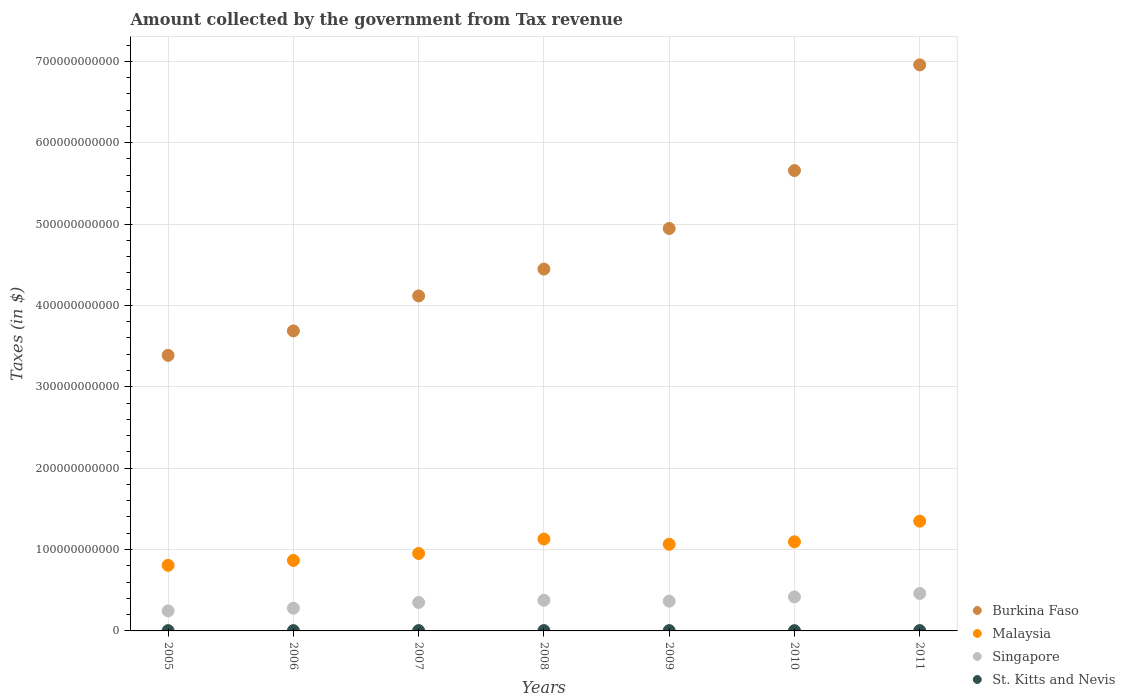Is the number of dotlines equal to the number of legend labels?
Offer a terse response. Yes. What is the amount collected by the government from tax revenue in Malaysia in 2006?
Give a very brief answer. 8.66e+1. Across all years, what is the maximum amount collected by the government from tax revenue in Burkina Faso?
Offer a very short reply. 6.96e+11. Across all years, what is the minimum amount collected by the government from tax revenue in Burkina Faso?
Provide a short and direct response. 3.39e+11. What is the total amount collected by the government from tax revenue in St. Kitts and Nevis in the graph?
Make the answer very short. 2.68e+09. What is the difference between the amount collected by the government from tax revenue in Singapore in 2005 and that in 2006?
Offer a very short reply. -3.31e+09. What is the difference between the amount collected by the government from tax revenue in Burkina Faso in 2010 and the amount collected by the government from tax revenue in Malaysia in 2007?
Give a very brief answer. 4.71e+11. What is the average amount collected by the government from tax revenue in Singapore per year?
Your answer should be very brief. 3.57e+1. In the year 2007, what is the difference between the amount collected by the government from tax revenue in Burkina Faso and amount collected by the government from tax revenue in Malaysia?
Keep it short and to the point. 3.17e+11. In how many years, is the amount collected by the government from tax revenue in Burkina Faso greater than 700000000000 $?
Your answer should be very brief. 0. What is the ratio of the amount collected by the government from tax revenue in Malaysia in 2006 to that in 2010?
Your answer should be very brief. 0.79. Is the amount collected by the government from tax revenue in Malaysia in 2006 less than that in 2010?
Give a very brief answer. Yes. What is the difference between the highest and the second highest amount collected by the government from tax revenue in Singapore?
Your response must be concise. 4.24e+09. What is the difference between the highest and the lowest amount collected by the government from tax revenue in Malaysia?
Offer a very short reply. 5.43e+1. Is the sum of the amount collected by the government from tax revenue in Burkina Faso in 2006 and 2008 greater than the maximum amount collected by the government from tax revenue in Singapore across all years?
Give a very brief answer. Yes. How many years are there in the graph?
Offer a terse response. 7. What is the difference between two consecutive major ticks on the Y-axis?
Keep it short and to the point. 1.00e+11. Does the graph contain any zero values?
Provide a succinct answer. No. Does the graph contain grids?
Ensure brevity in your answer.  Yes. What is the title of the graph?
Offer a very short reply. Amount collected by the government from Tax revenue. Does "Nicaragua" appear as one of the legend labels in the graph?
Your answer should be compact. No. What is the label or title of the Y-axis?
Ensure brevity in your answer.  Taxes (in $). What is the Taxes (in $) in Burkina Faso in 2005?
Your answer should be very brief. 3.39e+11. What is the Taxes (in $) in Malaysia in 2005?
Keep it short and to the point. 8.06e+1. What is the Taxes (in $) of Singapore in 2005?
Offer a very short reply. 2.46e+1. What is the Taxes (in $) in St. Kitts and Nevis in 2005?
Your answer should be compact. 3.44e+08. What is the Taxes (in $) of Burkina Faso in 2006?
Your answer should be compact. 3.69e+11. What is the Taxes (in $) of Malaysia in 2006?
Keep it short and to the point. 8.66e+1. What is the Taxes (in $) in Singapore in 2006?
Provide a succinct answer. 2.79e+1. What is the Taxes (in $) in St. Kitts and Nevis in 2006?
Offer a terse response. 3.74e+08. What is the Taxes (in $) in Burkina Faso in 2007?
Offer a terse response. 4.12e+11. What is the Taxes (in $) in Malaysia in 2007?
Provide a short and direct response. 9.52e+1. What is the Taxes (in $) in Singapore in 2007?
Your answer should be very brief. 3.50e+1. What is the Taxes (in $) in St. Kitts and Nevis in 2007?
Provide a succinct answer. 4.00e+08. What is the Taxes (in $) of Burkina Faso in 2008?
Your answer should be compact. 4.45e+11. What is the Taxes (in $) of Malaysia in 2008?
Ensure brevity in your answer.  1.13e+11. What is the Taxes (in $) in Singapore in 2008?
Keep it short and to the point. 3.77e+1. What is the Taxes (in $) of St. Kitts and Nevis in 2008?
Your response must be concise. 4.21e+08. What is the Taxes (in $) of Burkina Faso in 2009?
Make the answer very short. 4.95e+11. What is the Taxes (in $) of Malaysia in 2009?
Provide a short and direct response. 1.07e+11. What is the Taxes (in $) in Singapore in 2009?
Your response must be concise. 3.66e+1. What is the Taxes (in $) of St. Kitts and Nevis in 2009?
Provide a short and direct response. 3.94e+08. What is the Taxes (in $) of Burkina Faso in 2010?
Keep it short and to the point. 5.66e+11. What is the Taxes (in $) in Malaysia in 2010?
Keep it short and to the point. 1.10e+11. What is the Taxes (in $) in Singapore in 2010?
Provide a succinct answer. 4.18e+1. What is the Taxes (in $) in St. Kitts and Nevis in 2010?
Provide a succinct answer. 3.43e+08. What is the Taxes (in $) in Burkina Faso in 2011?
Make the answer very short. 6.96e+11. What is the Taxes (in $) of Malaysia in 2011?
Give a very brief answer. 1.35e+11. What is the Taxes (in $) of Singapore in 2011?
Your answer should be very brief. 4.60e+1. What is the Taxes (in $) of St. Kitts and Nevis in 2011?
Your answer should be very brief. 4.08e+08. Across all years, what is the maximum Taxes (in $) of Burkina Faso?
Keep it short and to the point. 6.96e+11. Across all years, what is the maximum Taxes (in $) of Malaysia?
Keep it short and to the point. 1.35e+11. Across all years, what is the maximum Taxes (in $) of Singapore?
Give a very brief answer. 4.60e+1. Across all years, what is the maximum Taxes (in $) in St. Kitts and Nevis?
Your answer should be very brief. 4.21e+08. Across all years, what is the minimum Taxes (in $) in Burkina Faso?
Offer a terse response. 3.39e+11. Across all years, what is the minimum Taxes (in $) in Malaysia?
Ensure brevity in your answer.  8.06e+1. Across all years, what is the minimum Taxes (in $) of Singapore?
Your response must be concise. 2.46e+1. Across all years, what is the minimum Taxes (in $) of St. Kitts and Nevis?
Your answer should be compact. 3.43e+08. What is the total Taxes (in $) of Burkina Faso in the graph?
Keep it short and to the point. 3.32e+12. What is the total Taxes (in $) of Malaysia in the graph?
Your answer should be compact. 7.26e+11. What is the total Taxes (in $) of Singapore in the graph?
Give a very brief answer. 2.50e+11. What is the total Taxes (in $) of St. Kitts and Nevis in the graph?
Provide a short and direct response. 2.68e+09. What is the difference between the Taxes (in $) in Burkina Faso in 2005 and that in 2006?
Offer a terse response. -3.00e+1. What is the difference between the Taxes (in $) of Malaysia in 2005 and that in 2006?
Your answer should be compact. -6.04e+09. What is the difference between the Taxes (in $) of Singapore in 2005 and that in 2006?
Give a very brief answer. -3.31e+09. What is the difference between the Taxes (in $) in St. Kitts and Nevis in 2005 and that in 2006?
Keep it short and to the point. -3.00e+07. What is the difference between the Taxes (in $) in Burkina Faso in 2005 and that in 2007?
Provide a short and direct response. -7.30e+1. What is the difference between the Taxes (in $) in Malaysia in 2005 and that in 2007?
Offer a terse response. -1.46e+1. What is the difference between the Taxes (in $) in Singapore in 2005 and that in 2007?
Give a very brief answer. -1.03e+1. What is the difference between the Taxes (in $) in St. Kitts and Nevis in 2005 and that in 2007?
Ensure brevity in your answer.  -5.55e+07. What is the difference between the Taxes (in $) in Burkina Faso in 2005 and that in 2008?
Make the answer very short. -1.06e+11. What is the difference between the Taxes (in $) in Malaysia in 2005 and that in 2008?
Offer a terse response. -3.23e+1. What is the difference between the Taxes (in $) in Singapore in 2005 and that in 2008?
Make the answer very short. -1.31e+1. What is the difference between the Taxes (in $) in St. Kitts and Nevis in 2005 and that in 2008?
Your answer should be compact. -7.66e+07. What is the difference between the Taxes (in $) of Burkina Faso in 2005 and that in 2009?
Ensure brevity in your answer.  -1.56e+11. What is the difference between the Taxes (in $) of Malaysia in 2005 and that in 2009?
Provide a short and direct response. -2.59e+1. What is the difference between the Taxes (in $) of Singapore in 2005 and that in 2009?
Your answer should be compact. -1.20e+1. What is the difference between the Taxes (in $) in St. Kitts and Nevis in 2005 and that in 2009?
Offer a very short reply. -5.04e+07. What is the difference between the Taxes (in $) in Burkina Faso in 2005 and that in 2010?
Provide a succinct answer. -2.27e+11. What is the difference between the Taxes (in $) of Malaysia in 2005 and that in 2010?
Ensure brevity in your answer.  -2.89e+1. What is the difference between the Taxes (in $) in Singapore in 2005 and that in 2010?
Provide a succinct answer. -1.72e+1. What is the difference between the Taxes (in $) of St. Kitts and Nevis in 2005 and that in 2010?
Offer a terse response. 1.10e+06. What is the difference between the Taxes (in $) in Burkina Faso in 2005 and that in 2011?
Your answer should be compact. -3.57e+11. What is the difference between the Taxes (in $) of Malaysia in 2005 and that in 2011?
Provide a succinct answer. -5.43e+1. What is the difference between the Taxes (in $) in Singapore in 2005 and that in 2011?
Make the answer very short. -2.14e+1. What is the difference between the Taxes (in $) of St. Kitts and Nevis in 2005 and that in 2011?
Your answer should be very brief. -6.39e+07. What is the difference between the Taxes (in $) in Burkina Faso in 2006 and that in 2007?
Your answer should be compact. -4.30e+1. What is the difference between the Taxes (in $) in Malaysia in 2006 and that in 2007?
Your answer should be compact. -8.54e+09. What is the difference between the Taxes (in $) of Singapore in 2006 and that in 2007?
Give a very brief answer. -7.02e+09. What is the difference between the Taxes (in $) in St. Kitts and Nevis in 2006 and that in 2007?
Your response must be concise. -2.55e+07. What is the difference between the Taxes (in $) of Burkina Faso in 2006 and that in 2008?
Your answer should be very brief. -7.60e+1. What is the difference between the Taxes (in $) in Malaysia in 2006 and that in 2008?
Provide a succinct answer. -2.63e+1. What is the difference between the Taxes (in $) in Singapore in 2006 and that in 2008?
Your answer should be very brief. -9.74e+09. What is the difference between the Taxes (in $) of St. Kitts and Nevis in 2006 and that in 2008?
Provide a succinct answer. -4.66e+07. What is the difference between the Taxes (in $) of Burkina Faso in 2006 and that in 2009?
Provide a succinct answer. -1.26e+11. What is the difference between the Taxes (in $) in Malaysia in 2006 and that in 2009?
Offer a very short reply. -1.99e+1. What is the difference between the Taxes (in $) of Singapore in 2006 and that in 2009?
Provide a succinct answer. -8.64e+09. What is the difference between the Taxes (in $) of St. Kitts and Nevis in 2006 and that in 2009?
Give a very brief answer. -2.04e+07. What is the difference between the Taxes (in $) of Burkina Faso in 2006 and that in 2010?
Provide a succinct answer. -1.97e+11. What is the difference between the Taxes (in $) of Malaysia in 2006 and that in 2010?
Your response must be concise. -2.29e+1. What is the difference between the Taxes (in $) of Singapore in 2006 and that in 2010?
Your response must be concise. -1.39e+1. What is the difference between the Taxes (in $) in St. Kitts and Nevis in 2006 and that in 2010?
Ensure brevity in your answer.  3.11e+07. What is the difference between the Taxes (in $) of Burkina Faso in 2006 and that in 2011?
Provide a short and direct response. -3.27e+11. What is the difference between the Taxes (in $) in Malaysia in 2006 and that in 2011?
Your response must be concise. -4.83e+1. What is the difference between the Taxes (in $) of Singapore in 2006 and that in 2011?
Give a very brief answer. -1.81e+1. What is the difference between the Taxes (in $) of St. Kitts and Nevis in 2006 and that in 2011?
Ensure brevity in your answer.  -3.39e+07. What is the difference between the Taxes (in $) of Burkina Faso in 2007 and that in 2008?
Your response must be concise. -3.30e+1. What is the difference between the Taxes (in $) of Malaysia in 2007 and that in 2008?
Offer a very short reply. -1.77e+1. What is the difference between the Taxes (in $) in Singapore in 2007 and that in 2008?
Keep it short and to the point. -2.72e+09. What is the difference between the Taxes (in $) of St. Kitts and Nevis in 2007 and that in 2008?
Offer a terse response. -2.11e+07. What is the difference between the Taxes (in $) of Burkina Faso in 2007 and that in 2009?
Offer a terse response. -8.29e+1. What is the difference between the Taxes (in $) of Malaysia in 2007 and that in 2009?
Provide a short and direct response. -1.13e+1. What is the difference between the Taxes (in $) of Singapore in 2007 and that in 2009?
Your answer should be very brief. -1.62e+09. What is the difference between the Taxes (in $) of St. Kitts and Nevis in 2007 and that in 2009?
Your response must be concise. 5.10e+06. What is the difference between the Taxes (in $) of Burkina Faso in 2007 and that in 2010?
Offer a very short reply. -1.54e+11. What is the difference between the Taxes (in $) of Malaysia in 2007 and that in 2010?
Keep it short and to the point. -1.43e+1. What is the difference between the Taxes (in $) in Singapore in 2007 and that in 2010?
Your answer should be compact. -6.85e+09. What is the difference between the Taxes (in $) in St. Kitts and Nevis in 2007 and that in 2010?
Your answer should be compact. 5.66e+07. What is the difference between the Taxes (in $) of Burkina Faso in 2007 and that in 2011?
Your answer should be compact. -2.84e+11. What is the difference between the Taxes (in $) of Malaysia in 2007 and that in 2011?
Provide a short and direct response. -3.97e+1. What is the difference between the Taxes (in $) in Singapore in 2007 and that in 2011?
Ensure brevity in your answer.  -1.11e+1. What is the difference between the Taxes (in $) of St. Kitts and Nevis in 2007 and that in 2011?
Provide a succinct answer. -8.40e+06. What is the difference between the Taxes (in $) of Burkina Faso in 2008 and that in 2009?
Your answer should be very brief. -4.99e+1. What is the difference between the Taxes (in $) in Malaysia in 2008 and that in 2009?
Make the answer very short. 6.39e+09. What is the difference between the Taxes (in $) in Singapore in 2008 and that in 2009?
Keep it short and to the point. 1.10e+09. What is the difference between the Taxes (in $) of St. Kitts and Nevis in 2008 and that in 2009?
Provide a short and direct response. 2.62e+07. What is the difference between the Taxes (in $) of Burkina Faso in 2008 and that in 2010?
Your response must be concise. -1.21e+11. What is the difference between the Taxes (in $) in Malaysia in 2008 and that in 2010?
Ensure brevity in your answer.  3.38e+09. What is the difference between the Taxes (in $) of Singapore in 2008 and that in 2010?
Give a very brief answer. -4.13e+09. What is the difference between the Taxes (in $) of St. Kitts and Nevis in 2008 and that in 2010?
Make the answer very short. 7.77e+07. What is the difference between the Taxes (in $) of Burkina Faso in 2008 and that in 2011?
Give a very brief answer. -2.51e+11. What is the difference between the Taxes (in $) in Malaysia in 2008 and that in 2011?
Make the answer very short. -2.20e+1. What is the difference between the Taxes (in $) of Singapore in 2008 and that in 2011?
Offer a terse response. -8.37e+09. What is the difference between the Taxes (in $) of St. Kitts and Nevis in 2008 and that in 2011?
Make the answer very short. 1.27e+07. What is the difference between the Taxes (in $) of Burkina Faso in 2009 and that in 2010?
Keep it short and to the point. -7.12e+1. What is the difference between the Taxes (in $) in Malaysia in 2009 and that in 2010?
Make the answer very short. -3.01e+09. What is the difference between the Taxes (in $) of Singapore in 2009 and that in 2010?
Your response must be concise. -5.22e+09. What is the difference between the Taxes (in $) in St. Kitts and Nevis in 2009 and that in 2010?
Your answer should be compact. 5.15e+07. What is the difference between the Taxes (in $) in Burkina Faso in 2009 and that in 2011?
Offer a terse response. -2.01e+11. What is the difference between the Taxes (in $) of Malaysia in 2009 and that in 2011?
Offer a terse response. -2.84e+1. What is the difference between the Taxes (in $) in Singapore in 2009 and that in 2011?
Provide a short and direct response. -9.47e+09. What is the difference between the Taxes (in $) in St. Kitts and Nevis in 2009 and that in 2011?
Your response must be concise. -1.35e+07. What is the difference between the Taxes (in $) of Burkina Faso in 2010 and that in 2011?
Your answer should be very brief. -1.30e+11. What is the difference between the Taxes (in $) in Malaysia in 2010 and that in 2011?
Keep it short and to the point. -2.54e+1. What is the difference between the Taxes (in $) in Singapore in 2010 and that in 2011?
Offer a very short reply. -4.24e+09. What is the difference between the Taxes (in $) in St. Kitts and Nevis in 2010 and that in 2011?
Your answer should be compact. -6.50e+07. What is the difference between the Taxes (in $) in Burkina Faso in 2005 and the Taxes (in $) in Malaysia in 2006?
Give a very brief answer. 2.52e+11. What is the difference between the Taxes (in $) of Burkina Faso in 2005 and the Taxes (in $) of Singapore in 2006?
Offer a terse response. 3.11e+11. What is the difference between the Taxes (in $) in Burkina Faso in 2005 and the Taxes (in $) in St. Kitts and Nevis in 2006?
Offer a very short reply. 3.38e+11. What is the difference between the Taxes (in $) in Malaysia in 2005 and the Taxes (in $) in Singapore in 2006?
Provide a succinct answer. 5.27e+1. What is the difference between the Taxes (in $) in Malaysia in 2005 and the Taxes (in $) in St. Kitts and Nevis in 2006?
Your answer should be very brief. 8.02e+1. What is the difference between the Taxes (in $) of Singapore in 2005 and the Taxes (in $) of St. Kitts and Nevis in 2006?
Ensure brevity in your answer.  2.43e+1. What is the difference between the Taxes (in $) of Burkina Faso in 2005 and the Taxes (in $) of Malaysia in 2007?
Make the answer very short. 2.43e+11. What is the difference between the Taxes (in $) in Burkina Faso in 2005 and the Taxes (in $) in Singapore in 2007?
Give a very brief answer. 3.04e+11. What is the difference between the Taxes (in $) of Burkina Faso in 2005 and the Taxes (in $) of St. Kitts and Nevis in 2007?
Provide a succinct answer. 3.38e+11. What is the difference between the Taxes (in $) in Malaysia in 2005 and the Taxes (in $) in Singapore in 2007?
Provide a succinct answer. 4.56e+1. What is the difference between the Taxes (in $) in Malaysia in 2005 and the Taxes (in $) in St. Kitts and Nevis in 2007?
Offer a very short reply. 8.02e+1. What is the difference between the Taxes (in $) of Singapore in 2005 and the Taxes (in $) of St. Kitts and Nevis in 2007?
Your answer should be compact. 2.42e+1. What is the difference between the Taxes (in $) of Burkina Faso in 2005 and the Taxes (in $) of Malaysia in 2008?
Your answer should be compact. 2.26e+11. What is the difference between the Taxes (in $) of Burkina Faso in 2005 and the Taxes (in $) of Singapore in 2008?
Your answer should be very brief. 3.01e+11. What is the difference between the Taxes (in $) of Burkina Faso in 2005 and the Taxes (in $) of St. Kitts and Nevis in 2008?
Ensure brevity in your answer.  3.38e+11. What is the difference between the Taxes (in $) in Malaysia in 2005 and the Taxes (in $) in Singapore in 2008?
Your response must be concise. 4.29e+1. What is the difference between the Taxes (in $) of Malaysia in 2005 and the Taxes (in $) of St. Kitts and Nevis in 2008?
Give a very brief answer. 8.02e+1. What is the difference between the Taxes (in $) of Singapore in 2005 and the Taxes (in $) of St. Kitts and Nevis in 2008?
Your response must be concise. 2.42e+1. What is the difference between the Taxes (in $) of Burkina Faso in 2005 and the Taxes (in $) of Malaysia in 2009?
Your answer should be compact. 2.32e+11. What is the difference between the Taxes (in $) of Burkina Faso in 2005 and the Taxes (in $) of Singapore in 2009?
Your response must be concise. 3.02e+11. What is the difference between the Taxes (in $) in Burkina Faso in 2005 and the Taxes (in $) in St. Kitts and Nevis in 2009?
Provide a succinct answer. 3.38e+11. What is the difference between the Taxes (in $) in Malaysia in 2005 and the Taxes (in $) in Singapore in 2009?
Your answer should be very brief. 4.40e+1. What is the difference between the Taxes (in $) of Malaysia in 2005 and the Taxes (in $) of St. Kitts and Nevis in 2009?
Provide a short and direct response. 8.02e+1. What is the difference between the Taxes (in $) of Singapore in 2005 and the Taxes (in $) of St. Kitts and Nevis in 2009?
Ensure brevity in your answer.  2.42e+1. What is the difference between the Taxes (in $) in Burkina Faso in 2005 and the Taxes (in $) in Malaysia in 2010?
Your response must be concise. 2.29e+11. What is the difference between the Taxes (in $) of Burkina Faso in 2005 and the Taxes (in $) of Singapore in 2010?
Give a very brief answer. 2.97e+11. What is the difference between the Taxes (in $) of Burkina Faso in 2005 and the Taxes (in $) of St. Kitts and Nevis in 2010?
Keep it short and to the point. 3.38e+11. What is the difference between the Taxes (in $) of Malaysia in 2005 and the Taxes (in $) of Singapore in 2010?
Provide a short and direct response. 3.88e+1. What is the difference between the Taxes (in $) of Malaysia in 2005 and the Taxes (in $) of St. Kitts and Nevis in 2010?
Provide a short and direct response. 8.02e+1. What is the difference between the Taxes (in $) of Singapore in 2005 and the Taxes (in $) of St. Kitts and Nevis in 2010?
Ensure brevity in your answer.  2.43e+1. What is the difference between the Taxes (in $) of Burkina Faso in 2005 and the Taxes (in $) of Malaysia in 2011?
Give a very brief answer. 2.04e+11. What is the difference between the Taxes (in $) in Burkina Faso in 2005 and the Taxes (in $) in Singapore in 2011?
Your answer should be compact. 2.93e+11. What is the difference between the Taxes (in $) of Burkina Faso in 2005 and the Taxes (in $) of St. Kitts and Nevis in 2011?
Provide a short and direct response. 3.38e+11. What is the difference between the Taxes (in $) in Malaysia in 2005 and the Taxes (in $) in Singapore in 2011?
Your answer should be compact. 3.45e+1. What is the difference between the Taxes (in $) in Malaysia in 2005 and the Taxes (in $) in St. Kitts and Nevis in 2011?
Offer a very short reply. 8.02e+1. What is the difference between the Taxes (in $) of Singapore in 2005 and the Taxes (in $) of St. Kitts and Nevis in 2011?
Make the answer very short. 2.42e+1. What is the difference between the Taxes (in $) of Burkina Faso in 2006 and the Taxes (in $) of Malaysia in 2007?
Provide a short and direct response. 2.74e+11. What is the difference between the Taxes (in $) in Burkina Faso in 2006 and the Taxes (in $) in Singapore in 2007?
Keep it short and to the point. 3.34e+11. What is the difference between the Taxes (in $) in Burkina Faso in 2006 and the Taxes (in $) in St. Kitts and Nevis in 2007?
Your answer should be very brief. 3.68e+11. What is the difference between the Taxes (in $) in Malaysia in 2006 and the Taxes (in $) in Singapore in 2007?
Make the answer very short. 5.17e+1. What is the difference between the Taxes (in $) of Malaysia in 2006 and the Taxes (in $) of St. Kitts and Nevis in 2007?
Give a very brief answer. 8.62e+1. What is the difference between the Taxes (in $) of Singapore in 2006 and the Taxes (in $) of St. Kitts and Nevis in 2007?
Give a very brief answer. 2.75e+1. What is the difference between the Taxes (in $) of Burkina Faso in 2006 and the Taxes (in $) of Malaysia in 2008?
Offer a terse response. 2.56e+11. What is the difference between the Taxes (in $) of Burkina Faso in 2006 and the Taxes (in $) of Singapore in 2008?
Your answer should be compact. 3.31e+11. What is the difference between the Taxes (in $) of Burkina Faso in 2006 and the Taxes (in $) of St. Kitts and Nevis in 2008?
Provide a succinct answer. 3.68e+11. What is the difference between the Taxes (in $) in Malaysia in 2006 and the Taxes (in $) in Singapore in 2008?
Make the answer very short. 4.90e+1. What is the difference between the Taxes (in $) of Malaysia in 2006 and the Taxes (in $) of St. Kitts and Nevis in 2008?
Offer a very short reply. 8.62e+1. What is the difference between the Taxes (in $) in Singapore in 2006 and the Taxes (in $) in St. Kitts and Nevis in 2008?
Offer a terse response. 2.75e+1. What is the difference between the Taxes (in $) of Burkina Faso in 2006 and the Taxes (in $) of Malaysia in 2009?
Your response must be concise. 2.62e+11. What is the difference between the Taxes (in $) in Burkina Faso in 2006 and the Taxes (in $) in Singapore in 2009?
Your response must be concise. 3.32e+11. What is the difference between the Taxes (in $) of Burkina Faso in 2006 and the Taxes (in $) of St. Kitts and Nevis in 2009?
Your response must be concise. 3.68e+11. What is the difference between the Taxes (in $) in Malaysia in 2006 and the Taxes (in $) in Singapore in 2009?
Keep it short and to the point. 5.00e+1. What is the difference between the Taxes (in $) in Malaysia in 2006 and the Taxes (in $) in St. Kitts and Nevis in 2009?
Provide a succinct answer. 8.62e+1. What is the difference between the Taxes (in $) of Singapore in 2006 and the Taxes (in $) of St. Kitts and Nevis in 2009?
Provide a short and direct response. 2.75e+1. What is the difference between the Taxes (in $) of Burkina Faso in 2006 and the Taxes (in $) of Malaysia in 2010?
Your answer should be very brief. 2.59e+11. What is the difference between the Taxes (in $) of Burkina Faso in 2006 and the Taxes (in $) of Singapore in 2010?
Your response must be concise. 3.27e+11. What is the difference between the Taxes (in $) in Burkina Faso in 2006 and the Taxes (in $) in St. Kitts and Nevis in 2010?
Ensure brevity in your answer.  3.68e+11. What is the difference between the Taxes (in $) in Malaysia in 2006 and the Taxes (in $) in Singapore in 2010?
Offer a terse response. 4.48e+1. What is the difference between the Taxes (in $) in Malaysia in 2006 and the Taxes (in $) in St. Kitts and Nevis in 2010?
Make the answer very short. 8.63e+1. What is the difference between the Taxes (in $) of Singapore in 2006 and the Taxes (in $) of St. Kitts and Nevis in 2010?
Provide a short and direct response. 2.76e+1. What is the difference between the Taxes (in $) of Burkina Faso in 2006 and the Taxes (in $) of Malaysia in 2011?
Your answer should be compact. 2.34e+11. What is the difference between the Taxes (in $) of Burkina Faso in 2006 and the Taxes (in $) of Singapore in 2011?
Provide a short and direct response. 3.23e+11. What is the difference between the Taxes (in $) of Burkina Faso in 2006 and the Taxes (in $) of St. Kitts and Nevis in 2011?
Offer a very short reply. 3.68e+11. What is the difference between the Taxes (in $) of Malaysia in 2006 and the Taxes (in $) of Singapore in 2011?
Your response must be concise. 4.06e+1. What is the difference between the Taxes (in $) of Malaysia in 2006 and the Taxes (in $) of St. Kitts and Nevis in 2011?
Provide a short and direct response. 8.62e+1. What is the difference between the Taxes (in $) in Singapore in 2006 and the Taxes (in $) in St. Kitts and Nevis in 2011?
Make the answer very short. 2.75e+1. What is the difference between the Taxes (in $) of Burkina Faso in 2007 and the Taxes (in $) of Malaysia in 2008?
Make the answer very short. 2.99e+11. What is the difference between the Taxes (in $) in Burkina Faso in 2007 and the Taxes (in $) in Singapore in 2008?
Your response must be concise. 3.74e+11. What is the difference between the Taxes (in $) in Burkina Faso in 2007 and the Taxes (in $) in St. Kitts and Nevis in 2008?
Offer a very short reply. 4.11e+11. What is the difference between the Taxes (in $) of Malaysia in 2007 and the Taxes (in $) of Singapore in 2008?
Offer a very short reply. 5.75e+1. What is the difference between the Taxes (in $) in Malaysia in 2007 and the Taxes (in $) in St. Kitts and Nevis in 2008?
Offer a very short reply. 9.47e+1. What is the difference between the Taxes (in $) in Singapore in 2007 and the Taxes (in $) in St. Kitts and Nevis in 2008?
Your response must be concise. 3.45e+1. What is the difference between the Taxes (in $) of Burkina Faso in 2007 and the Taxes (in $) of Malaysia in 2009?
Make the answer very short. 3.05e+11. What is the difference between the Taxes (in $) in Burkina Faso in 2007 and the Taxes (in $) in Singapore in 2009?
Offer a terse response. 3.75e+11. What is the difference between the Taxes (in $) in Burkina Faso in 2007 and the Taxes (in $) in St. Kitts and Nevis in 2009?
Keep it short and to the point. 4.11e+11. What is the difference between the Taxes (in $) of Malaysia in 2007 and the Taxes (in $) of Singapore in 2009?
Provide a succinct answer. 5.86e+1. What is the difference between the Taxes (in $) of Malaysia in 2007 and the Taxes (in $) of St. Kitts and Nevis in 2009?
Your response must be concise. 9.48e+1. What is the difference between the Taxes (in $) of Singapore in 2007 and the Taxes (in $) of St. Kitts and Nevis in 2009?
Offer a terse response. 3.46e+1. What is the difference between the Taxes (in $) of Burkina Faso in 2007 and the Taxes (in $) of Malaysia in 2010?
Offer a terse response. 3.02e+11. What is the difference between the Taxes (in $) in Burkina Faso in 2007 and the Taxes (in $) in Singapore in 2010?
Offer a terse response. 3.70e+11. What is the difference between the Taxes (in $) in Burkina Faso in 2007 and the Taxes (in $) in St. Kitts and Nevis in 2010?
Keep it short and to the point. 4.11e+11. What is the difference between the Taxes (in $) of Malaysia in 2007 and the Taxes (in $) of Singapore in 2010?
Make the answer very short. 5.34e+1. What is the difference between the Taxes (in $) in Malaysia in 2007 and the Taxes (in $) in St. Kitts and Nevis in 2010?
Ensure brevity in your answer.  9.48e+1. What is the difference between the Taxes (in $) in Singapore in 2007 and the Taxes (in $) in St. Kitts and Nevis in 2010?
Ensure brevity in your answer.  3.46e+1. What is the difference between the Taxes (in $) of Burkina Faso in 2007 and the Taxes (in $) of Malaysia in 2011?
Your answer should be compact. 2.77e+11. What is the difference between the Taxes (in $) of Burkina Faso in 2007 and the Taxes (in $) of Singapore in 2011?
Keep it short and to the point. 3.66e+11. What is the difference between the Taxes (in $) in Burkina Faso in 2007 and the Taxes (in $) in St. Kitts and Nevis in 2011?
Provide a short and direct response. 4.11e+11. What is the difference between the Taxes (in $) of Malaysia in 2007 and the Taxes (in $) of Singapore in 2011?
Provide a succinct answer. 4.91e+1. What is the difference between the Taxes (in $) of Malaysia in 2007 and the Taxes (in $) of St. Kitts and Nevis in 2011?
Provide a succinct answer. 9.48e+1. What is the difference between the Taxes (in $) in Singapore in 2007 and the Taxes (in $) in St. Kitts and Nevis in 2011?
Provide a short and direct response. 3.46e+1. What is the difference between the Taxes (in $) in Burkina Faso in 2008 and the Taxes (in $) in Malaysia in 2009?
Ensure brevity in your answer.  3.38e+11. What is the difference between the Taxes (in $) in Burkina Faso in 2008 and the Taxes (in $) in Singapore in 2009?
Offer a very short reply. 4.08e+11. What is the difference between the Taxes (in $) of Burkina Faso in 2008 and the Taxes (in $) of St. Kitts and Nevis in 2009?
Offer a very short reply. 4.44e+11. What is the difference between the Taxes (in $) in Malaysia in 2008 and the Taxes (in $) in Singapore in 2009?
Ensure brevity in your answer.  7.63e+1. What is the difference between the Taxes (in $) of Malaysia in 2008 and the Taxes (in $) of St. Kitts and Nevis in 2009?
Provide a short and direct response. 1.13e+11. What is the difference between the Taxes (in $) of Singapore in 2008 and the Taxes (in $) of St. Kitts and Nevis in 2009?
Give a very brief answer. 3.73e+1. What is the difference between the Taxes (in $) in Burkina Faso in 2008 and the Taxes (in $) in Malaysia in 2010?
Provide a succinct answer. 3.35e+11. What is the difference between the Taxes (in $) in Burkina Faso in 2008 and the Taxes (in $) in Singapore in 2010?
Offer a terse response. 4.03e+11. What is the difference between the Taxes (in $) in Burkina Faso in 2008 and the Taxes (in $) in St. Kitts and Nevis in 2010?
Ensure brevity in your answer.  4.44e+11. What is the difference between the Taxes (in $) of Malaysia in 2008 and the Taxes (in $) of Singapore in 2010?
Ensure brevity in your answer.  7.11e+1. What is the difference between the Taxes (in $) in Malaysia in 2008 and the Taxes (in $) in St. Kitts and Nevis in 2010?
Your response must be concise. 1.13e+11. What is the difference between the Taxes (in $) of Singapore in 2008 and the Taxes (in $) of St. Kitts and Nevis in 2010?
Ensure brevity in your answer.  3.73e+1. What is the difference between the Taxes (in $) of Burkina Faso in 2008 and the Taxes (in $) of Malaysia in 2011?
Your answer should be very brief. 3.10e+11. What is the difference between the Taxes (in $) in Burkina Faso in 2008 and the Taxes (in $) in Singapore in 2011?
Provide a short and direct response. 3.99e+11. What is the difference between the Taxes (in $) in Burkina Faso in 2008 and the Taxes (in $) in St. Kitts and Nevis in 2011?
Provide a succinct answer. 4.44e+11. What is the difference between the Taxes (in $) of Malaysia in 2008 and the Taxes (in $) of Singapore in 2011?
Provide a short and direct response. 6.68e+1. What is the difference between the Taxes (in $) of Malaysia in 2008 and the Taxes (in $) of St. Kitts and Nevis in 2011?
Offer a very short reply. 1.12e+11. What is the difference between the Taxes (in $) of Singapore in 2008 and the Taxes (in $) of St. Kitts and Nevis in 2011?
Provide a succinct answer. 3.73e+1. What is the difference between the Taxes (in $) of Burkina Faso in 2009 and the Taxes (in $) of Malaysia in 2010?
Give a very brief answer. 3.85e+11. What is the difference between the Taxes (in $) of Burkina Faso in 2009 and the Taxes (in $) of Singapore in 2010?
Offer a very short reply. 4.53e+11. What is the difference between the Taxes (in $) in Burkina Faso in 2009 and the Taxes (in $) in St. Kitts and Nevis in 2010?
Your response must be concise. 4.94e+11. What is the difference between the Taxes (in $) in Malaysia in 2009 and the Taxes (in $) in Singapore in 2010?
Your response must be concise. 6.47e+1. What is the difference between the Taxes (in $) in Malaysia in 2009 and the Taxes (in $) in St. Kitts and Nevis in 2010?
Make the answer very short. 1.06e+11. What is the difference between the Taxes (in $) in Singapore in 2009 and the Taxes (in $) in St. Kitts and Nevis in 2010?
Your answer should be very brief. 3.62e+1. What is the difference between the Taxes (in $) in Burkina Faso in 2009 and the Taxes (in $) in Malaysia in 2011?
Your response must be concise. 3.60e+11. What is the difference between the Taxes (in $) in Burkina Faso in 2009 and the Taxes (in $) in Singapore in 2011?
Your answer should be very brief. 4.49e+11. What is the difference between the Taxes (in $) of Burkina Faso in 2009 and the Taxes (in $) of St. Kitts and Nevis in 2011?
Ensure brevity in your answer.  4.94e+11. What is the difference between the Taxes (in $) of Malaysia in 2009 and the Taxes (in $) of Singapore in 2011?
Provide a short and direct response. 6.05e+1. What is the difference between the Taxes (in $) of Malaysia in 2009 and the Taxes (in $) of St. Kitts and Nevis in 2011?
Your response must be concise. 1.06e+11. What is the difference between the Taxes (in $) in Singapore in 2009 and the Taxes (in $) in St. Kitts and Nevis in 2011?
Provide a short and direct response. 3.62e+1. What is the difference between the Taxes (in $) of Burkina Faso in 2010 and the Taxes (in $) of Malaysia in 2011?
Your response must be concise. 4.31e+11. What is the difference between the Taxes (in $) in Burkina Faso in 2010 and the Taxes (in $) in Singapore in 2011?
Ensure brevity in your answer.  5.20e+11. What is the difference between the Taxes (in $) in Burkina Faso in 2010 and the Taxes (in $) in St. Kitts and Nevis in 2011?
Your answer should be compact. 5.65e+11. What is the difference between the Taxes (in $) of Malaysia in 2010 and the Taxes (in $) of Singapore in 2011?
Offer a very short reply. 6.35e+1. What is the difference between the Taxes (in $) of Malaysia in 2010 and the Taxes (in $) of St. Kitts and Nevis in 2011?
Give a very brief answer. 1.09e+11. What is the difference between the Taxes (in $) of Singapore in 2010 and the Taxes (in $) of St. Kitts and Nevis in 2011?
Give a very brief answer. 4.14e+1. What is the average Taxes (in $) in Burkina Faso per year?
Provide a short and direct response. 4.74e+11. What is the average Taxes (in $) in Malaysia per year?
Offer a terse response. 1.04e+11. What is the average Taxes (in $) in Singapore per year?
Offer a terse response. 3.57e+1. What is the average Taxes (in $) in St. Kitts and Nevis per year?
Keep it short and to the point. 3.83e+08. In the year 2005, what is the difference between the Taxes (in $) in Burkina Faso and Taxes (in $) in Malaysia?
Provide a succinct answer. 2.58e+11. In the year 2005, what is the difference between the Taxes (in $) in Burkina Faso and Taxes (in $) in Singapore?
Your response must be concise. 3.14e+11. In the year 2005, what is the difference between the Taxes (in $) in Burkina Faso and Taxes (in $) in St. Kitts and Nevis?
Keep it short and to the point. 3.38e+11. In the year 2005, what is the difference between the Taxes (in $) in Malaysia and Taxes (in $) in Singapore?
Ensure brevity in your answer.  5.60e+1. In the year 2005, what is the difference between the Taxes (in $) in Malaysia and Taxes (in $) in St. Kitts and Nevis?
Make the answer very short. 8.02e+1. In the year 2005, what is the difference between the Taxes (in $) of Singapore and Taxes (in $) of St. Kitts and Nevis?
Provide a short and direct response. 2.43e+1. In the year 2006, what is the difference between the Taxes (in $) of Burkina Faso and Taxes (in $) of Malaysia?
Provide a succinct answer. 2.82e+11. In the year 2006, what is the difference between the Taxes (in $) of Burkina Faso and Taxes (in $) of Singapore?
Offer a terse response. 3.41e+11. In the year 2006, what is the difference between the Taxes (in $) of Burkina Faso and Taxes (in $) of St. Kitts and Nevis?
Keep it short and to the point. 3.68e+11. In the year 2006, what is the difference between the Taxes (in $) of Malaysia and Taxes (in $) of Singapore?
Provide a short and direct response. 5.87e+1. In the year 2006, what is the difference between the Taxes (in $) in Malaysia and Taxes (in $) in St. Kitts and Nevis?
Provide a succinct answer. 8.63e+1. In the year 2006, what is the difference between the Taxes (in $) in Singapore and Taxes (in $) in St. Kitts and Nevis?
Your answer should be very brief. 2.76e+1. In the year 2007, what is the difference between the Taxes (in $) in Burkina Faso and Taxes (in $) in Malaysia?
Your answer should be very brief. 3.17e+11. In the year 2007, what is the difference between the Taxes (in $) in Burkina Faso and Taxes (in $) in Singapore?
Provide a succinct answer. 3.77e+11. In the year 2007, what is the difference between the Taxes (in $) in Burkina Faso and Taxes (in $) in St. Kitts and Nevis?
Provide a short and direct response. 4.11e+11. In the year 2007, what is the difference between the Taxes (in $) of Malaysia and Taxes (in $) of Singapore?
Provide a short and direct response. 6.02e+1. In the year 2007, what is the difference between the Taxes (in $) in Malaysia and Taxes (in $) in St. Kitts and Nevis?
Your response must be concise. 9.48e+1. In the year 2007, what is the difference between the Taxes (in $) of Singapore and Taxes (in $) of St. Kitts and Nevis?
Offer a terse response. 3.46e+1. In the year 2008, what is the difference between the Taxes (in $) in Burkina Faso and Taxes (in $) in Malaysia?
Your response must be concise. 3.32e+11. In the year 2008, what is the difference between the Taxes (in $) of Burkina Faso and Taxes (in $) of Singapore?
Offer a terse response. 4.07e+11. In the year 2008, what is the difference between the Taxes (in $) of Burkina Faso and Taxes (in $) of St. Kitts and Nevis?
Your answer should be compact. 4.44e+11. In the year 2008, what is the difference between the Taxes (in $) in Malaysia and Taxes (in $) in Singapore?
Provide a short and direct response. 7.52e+1. In the year 2008, what is the difference between the Taxes (in $) of Malaysia and Taxes (in $) of St. Kitts and Nevis?
Your answer should be very brief. 1.12e+11. In the year 2008, what is the difference between the Taxes (in $) in Singapore and Taxes (in $) in St. Kitts and Nevis?
Ensure brevity in your answer.  3.73e+1. In the year 2009, what is the difference between the Taxes (in $) in Burkina Faso and Taxes (in $) in Malaysia?
Provide a short and direct response. 3.88e+11. In the year 2009, what is the difference between the Taxes (in $) of Burkina Faso and Taxes (in $) of Singapore?
Give a very brief answer. 4.58e+11. In the year 2009, what is the difference between the Taxes (in $) in Burkina Faso and Taxes (in $) in St. Kitts and Nevis?
Give a very brief answer. 4.94e+11. In the year 2009, what is the difference between the Taxes (in $) in Malaysia and Taxes (in $) in Singapore?
Keep it short and to the point. 6.99e+1. In the year 2009, what is the difference between the Taxes (in $) of Malaysia and Taxes (in $) of St. Kitts and Nevis?
Provide a short and direct response. 1.06e+11. In the year 2009, what is the difference between the Taxes (in $) in Singapore and Taxes (in $) in St. Kitts and Nevis?
Offer a very short reply. 3.62e+1. In the year 2010, what is the difference between the Taxes (in $) of Burkina Faso and Taxes (in $) of Malaysia?
Offer a very short reply. 4.56e+11. In the year 2010, what is the difference between the Taxes (in $) of Burkina Faso and Taxes (in $) of Singapore?
Keep it short and to the point. 5.24e+11. In the year 2010, what is the difference between the Taxes (in $) in Burkina Faso and Taxes (in $) in St. Kitts and Nevis?
Your answer should be compact. 5.65e+11. In the year 2010, what is the difference between the Taxes (in $) of Malaysia and Taxes (in $) of Singapore?
Give a very brief answer. 6.77e+1. In the year 2010, what is the difference between the Taxes (in $) of Malaysia and Taxes (in $) of St. Kitts and Nevis?
Provide a short and direct response. 1.09e+11. In the year 2010, what is the difference between the Taxes (in $) in Singapore and Taxes (in $) in St. Kitts and Nevis?
Offer a very short reply. 4.15e+1. In the year 2011, what is the difference between the Taxes (in $) in Burkina Faso and Taxes (in $) in Malaysia?
Provide a short and direct response. 5.61e+11. In the year 2011, what is the difference between the Taxes (in $) of Burkina Faso and Taxes (in $) of Singapore?
Offer a terse response. 6.50e+11. In the year 2011, what is the difference between the Taxes (in $) in Burkina Faso and Taxes (in $) in St. Kitts and Nevis?
Make the answer very short. 6.95e+11. In the year 2011, what is the difference between the Taxes (in $) in Malaysia and Taxes (in $) in Singapore?
Make the answer very short. 8.88e+1. In the year 2011, what is the difference between the Taxes (in $) of Malaysia and Taxes (in $) of St. Kitts and Nevis?
Your response must be concise. 1.34e+11. In the year 2011, what is the difference between the Taxes (in $) in Singapore and Taxes (in $) in St. Kitts and Nevis?
Ensure brevity in your answer.  4.56e+1. What is the ratio of the Taxes (in $) of Burkina Faso in 2005 to that in 2006?
Provide a succinct answer. 0.92. What is the ratio of the Taxes (in $) in Malaysia in 2005 to that in 2006?
Provide a short and direct response. 0.93. What is the ratio of the Taxes (in $) in Singapore in 2005 to that in 2006?
Your answer should be compact. 0.88. What is the ratio of the Taxes (in $) in St. Kitts and Nevis in 2005 to that in 2006?
Give a very brief answer. 0.92. What is the ratio of the Taxes (in $) in Burkina Faso in 2005 to that in 2007?
Offer a terse response. 0.82. What is the ratio of the Taxes (in $) of Malaysia in 2005 to that in 2007?
Your response must be concise. 0.85. What is the ratio of the Taxes (in $) of Singapore in 2005 to that in 2007?
Give a very brief answer. 0.7. What is the ratio of the Taxes (in $) of St. Kitts and Nevis in 2005 to that in 2007?
Give a very brief answer. 0.86. What is the ratio of the Taxes (in $) in Burkina Faso in 2005 to that in 2008?
Offer a terse response. 0.76. What is the ratio of the Taxes (in $) in Malaysia in 2005 to that in 2008?
Ensure brevity in your answer.  0.71. What is the ratio of the Taxes (in $) in Singapore in 2005 to that in 2008?
Offer a very short reply. 0.65. What is the ratio of the Taxes (in $) in St. Kitts and Nevis in 2005 to that in 2008?
Your answer should be very brief. 0.82. What is the ratio of the Taxes (in $) of Burkina Faso in 2005 to that in 2009?
Offer a very short reply. 0.68. What is the ratio of the Taxes (in $) of Malaysia in 2005 to that in 2009?
Provide a short and direct response. 0.76. What is the ratio of the Taxes (in $) in Singapore in 2005 to that in 2009?
Offer a very short reply. 0.67. What is the ratio of the Taxes (in $) of St. Kitts and Nevis in 2005 to that in 2009?
Your response must be concise. 0.87. What is the ratio of the Taxes (in $) of Burkina Faso in 2005 to that in 2010?
Provide a short and direct response. 0.6. What is the ratio of the Taxes (in $) of Malaysia in 2005 to that in 2010?
Make the answer very short. 0.74. What is the ratio of the Taxes (in $) of Singapore in 2005 to that in 2010?
Keep it short and to the point. 0.59. What is the ratio of the Taxes (in $) in Burkina Faso in 2005 to that in 2011?
Offer a terse response. 0.49. What is the ratio of the Taxes (in $) of Malaysia in 2005 to that in 2011?
Provide a succinct answer. 0.6. What is the ratio of the Taxes (in $) of Singapore in 2005 to that in 2011?
Ensure brevity in your answer.  0.53. What is the ratio of the Taxes (in $) in St. Kitts and Nevis in 2005 to that in 2011?
Make the answer very short. 0.84. What is the ratio of the Taxes (in $) of Burkina Faso in 2006 to that in 2007?
Provide a succinct answer. 0.9. What is the ratio of the Taxes (in $) in Malaysia in 2006 to that in 2007?
Provide a succinct answer. 0.91. What is the ratio of the Taxes (in $) in Singapore in 2006 to that in 2007?
Offer a very short reply. 0.8. What is the ratio of the Taxes (in $) in St. Kitts and Nevis in 2006 to that in 2007?
Offer a very short reply. 0.94. What is the ratio of the Taxes (in $) of Burkina Faso in 2006 to that in 2008?
Offer a terse response. 0.83. What is the ratio of the Taxes (in $) of Malaysia in 2006 to that in 2008?
Your answer should be compact. 0.77. What is the ratio of the Taxes (in $) in Singapore in 2006 to that in 2008?
Make the answer very short. 0.74. What is the ratio of the Taxes (in $) in St. Kitts and Nevis in 2006 to that in 2008?
Make the answer very short. 0.89. What is the ratio of the Taxes (in $) in Burkina Faso in 2006 to that in 2009?
Provide a short and direct response. 0.75. What is the ratio of the Taxes (in $) in Malaysia in 2006 to that in 2009?
Make the answer very short. 0.81. What is the ratio of the Taxes (in $) of Singapore in 2006 to that in 2009?
Keep it short and to the point. 0.76. What is the ratio of the Taxes (in $) of St. Kitts and Nevis in 2006 to that in 2009?
Offer a terse response. 0.95. What is the ratio of the Taxes (in $) of Burkina Faso in 2006 to that in 2010?
Your answer should be very brief. 0.65. What is the ratio of the Taxes (in $) of Malaysia in 2006 to that in 2010?
Make the answer very short. 0.79. What is the ratio of the Taxes (in $) of Singapore in 2006 to that in 2010?
Your answer should be compact. 0.67. What is the ratio of the Taxes (in $) of St. Kitts and Nevis in 2006 to that in 2010?
Provide a succinct answer. 1.09. What is the ratio of the Taxes (in $) in Burkina Faso in 2006 to that in 2011?
Your answer should be very brief. 0.53. What is the ratio of the Taxes (in $) of Malaysia in 2006 to that in 2011?
Provide a succinct answer. 0.64. What is the ratio of the Taxes (in $) of Singapore in 2006 to that in 2011?
Your answer should be very brief. 0.61. What is the ratio of the Taxes (in $) of St. Kitts and Nevis in 2006 to that in 2011?
Your answer should be compact. 0.92. What is the ratio of the Taxes (in $) in Burkina Faso in 2007 to that in 2008?
Provide a short and direct response. 0.93. What is the ratio of the Taxes (in $) of Malaysia in 2007 to that in 2008?
Your answer should be compact. 0.84. What is the ratio of the Taxes (in $) in Singapore in 2007 to that in 2008?
Give a very brief answer. 0.93. What is the ratio of the Taxes (in $) in St. Kitts and Nevis in 2007 to that in 2008?
Offer a terse response. 0.95. What is the ratio of the Taxes (in $) in Burkina Faso in 2007 to that in 2009?
Provide a short and direct response. 0.83. What is the ratio of the Taxes (in $) of Malaysia in 2007 to that in 2009?
Your response must be concise. 0.89. What is the ratio of the Taxes (in $) of Singapore in 2007 to that in 2009?
Give a very brief answer. 0.96. What is the ratio of the Taxes (in $) in St. Kitts and Nevis in 2007 to that in 2009?
Your answer should be very brief. 1.01. What is the ratio of the Taxes (in $) in Burkina Faso in 2007 to that in 2010?
Your response must be concise. 0.73. What is the ratio of the Taxes (in $) of Malaysia in 2007 to that in 2010?
Provide a short and direct response. 0.87. What is the ratio of the Taxes (in $) in Singapore in 2007 to that in 2010?
Your answer should be compact. 0.84. What is the ratio of the Taxes (in $) in St. Kitts and Nevis in 2007 to that in 2010?
Your answer should be very brief. 1.17. What is the ratio of the Taxes (in $) of Burkina Faso in 2007 to that in 2011?
Provide a succinct answer. 0.59. What is the ratio of the Taxes (in $) of Malaysia in 2007 to that in 2011?
Keep it short and to the point. 0.71. What is the ratio of the Taxes (in $) of Singapore in 2007 to that in 2011?
Ensure brevity in your answer.  0.76. What is the ratio of the Taxes (in $) in St. Kitts and Nevis in 2007 to that in 2011?
Your response must be concise. 0.98. What is the ratio of the Taxes (in $) in Burkina Faso in 2008 to that in 2009?
Provide a succinct answer. 0.9. What is the ratio of the Taxes (in $) of Malaysia in 2008 to that in 2009?
Your response must be concise. 1.06. What is the ratio of the Taxes (in $) of Singapore in 2008 to that in 2009?
Give a very brief answer. 1.03. What is the ratio of the Taxes (in $) in St. Kitts and Nevis in 2008 to that in 2009?
Ensure brevity in your answer.  1.07. What is the ratio of the Taxes (in $) in Burkina Faso in 2008 to that in 2010?
Your answer should be compact. 0.79. What is the ratio of the Taxes (in $) in Malaysia in 2008 to that in 2010?
Your answer should be very brief. 1.03. What is the ratio of the Taxes (in $) in Singapore in 2008 to that in 2010?
Provide a succinct answer. 0.9. What is the ratio of the Taxes (in $) of St. Kitts and Nevis in 2008 to that in 2010?
Offer a terse response. 1.23. What is the ratio of the Taxes (in $) in Burkina Faso in 2008 to that in 2011?
Ensure brevity in your answer.  0.64. What is the ratio of the Taxes (in $) of Malaysia in 2008 to that in 2011?
Your response must be concise. 0.84. What is the ratio of the Taxes (in $) in Singapore in 2008 to that in 2011?
Keep it short and to the point. 0.82. What is the ratio of the Taxes (in $) in St. Kitts and Nevis in 2008 to that in 2011?
Your response must be concise. 1.03. What is the ratio of the Taxes (in $) in Burkina Faso in 2009 to that in 2010?
Keep it short and to the point. 0.87. What is the ratio of the Taxes (in $) of Malaysia in 2009 to that in 2010?
Give a very brief answer. 0.97. What is the ratio of the Taxes (in $) of Singapore in 2009 to that in 2010?
Your response must be concise. 0.88. What is the ratio of the Taxes (in $) of St. Kitts and Nevis in 2009 to that in 2010?
Offer a terse response. 1.15. What is the ratio of the Taxes (in $) of Burkina Faso in 2009 to that in 2011?
Provide a succinct answer. 0.71. What is the ratio of the Taxes (in $) of Malaysia in 2009 to that in 2011?
Ensure brevity in your answer.  0.79. What is the ratio of the Taxes (in $) in Singapore in 2009 to that in 2011?
Your answer should be compact. 0.79. What is the ratio of the Taxes (in $) in St. Kitts and Nevis in 2009 to that in 2011?
Your answer should be very brief. 0.97. What is the ratio of the Taxes (in $) of Burkina Faso in 2010 to that in 2011?
Provide a succinct answer. 0.81. What is the ratio of the Taxes (in $) in Malaysia in 2010 to that in 2011?
Offer a very short reply. 0.81. What is the ratio of the Taxes (in $) of Singapore in 2010 to that in 2011?
Your answer should be compact. 0.91. What is the ratio of the Taxes (in $) in St. Kitts and Nevis in 2010 to that in 2011?
Give a very brief answer. 0.84. What is the difference between the highest and the second highest Taxes (in $) of Burkina Faso?
Your response must be concise. 1.30e+11. What is the difference between the highest and the second highest Taxes (in $) in Malaysia?
Keep it short and to the point. 2.20e+1. What is the difference between the highest and the second highest Taxes (in $) in Singapore?
Keep it short and to the point. 4.24e+09. What is the difference between the highest and the second highest Taxes (in $) of St. Kitts and Nevis?
Offer a very short reply. 1.27e+07. What is the difference between the highest and the lowest Taxes (in $) in Burkina Faso?
Ensure brevity in your answer.  3.57e+11. What is the difference between the highest and the lowest Taxes (in $) of Malaysia?
Your answer should be compact. 5.43e+1. What is the difference between the highest and the lowest Taxes (in $) in Singapore?
Ensure brevity in your answer.  2.14e+1. What is the difference between the highest and the lowest Taxes (in $) in St. Kitts and Nevis?
Keep it short and to the point. 7.77e+07. 